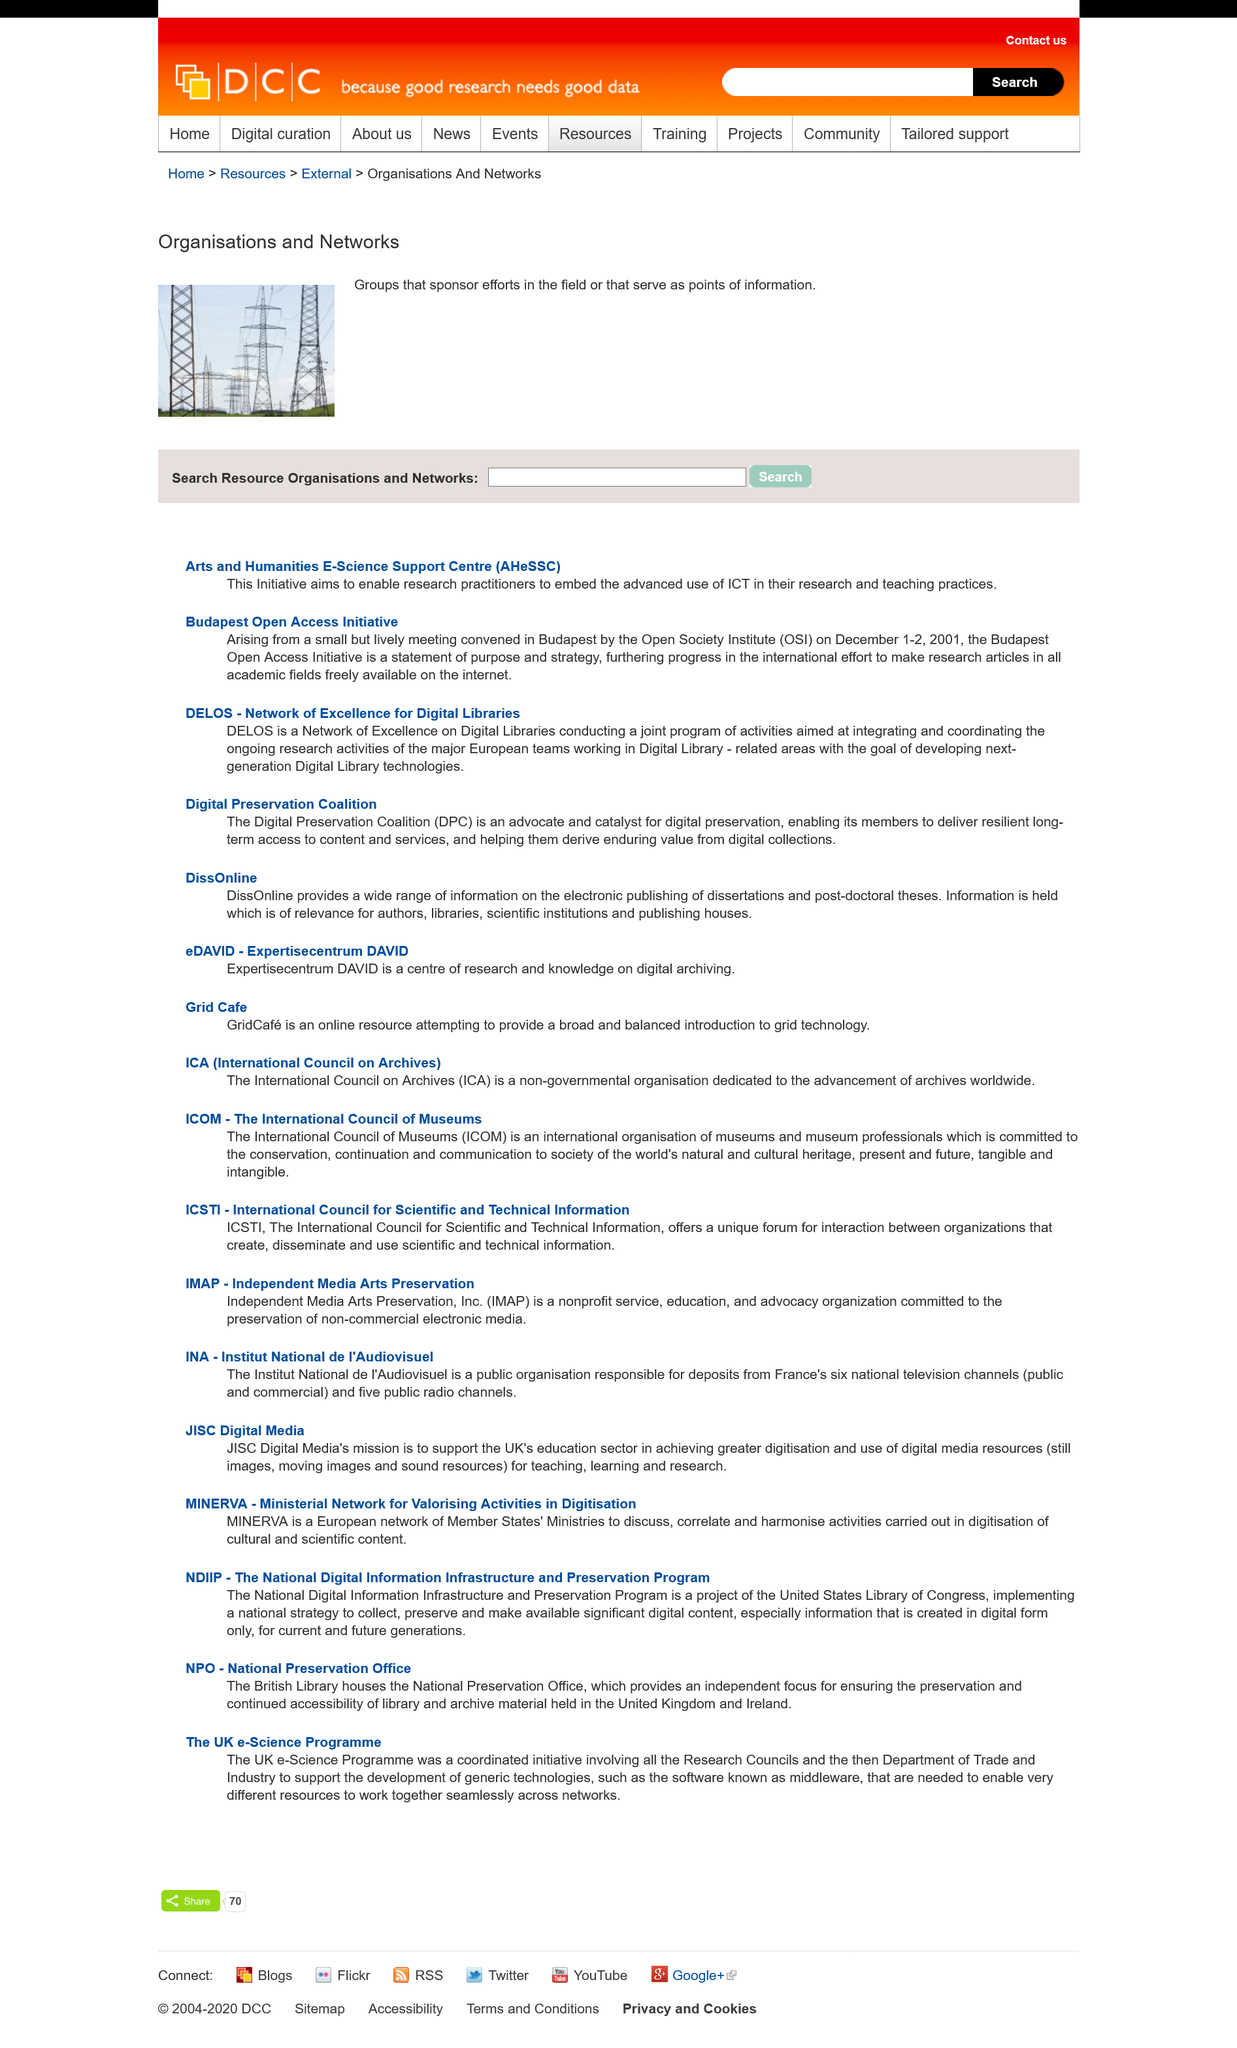Indicate a few pertinent items in this graphic. The acronym "AHeSSC" stands for "Arts and Humanities E-science Support Centre," which is a facility that provides support for scientific research in the fields of arts and humanities, including the use of electronic technology. The Network of Excellence for Digital Libraries is related to DELOS, which is a Network of Excellence for Digital Libraries. The Open Society Institute held a lively meeting in Budapest. 